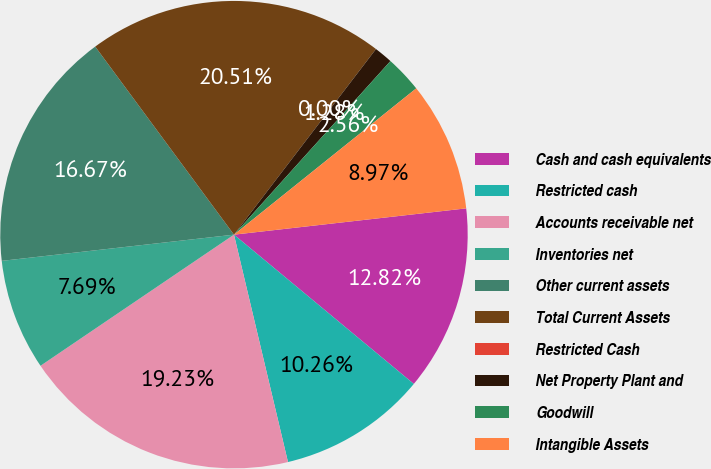<chart> <loc_0><loc_0><loc_500><loc_500><pie_chart><fcel>Cash and cash equivalents<fcel>Restricted cash<fcel>Accounts receivable net<fcel>Inventories net<fcel>Other current assets<fcel>Total Current Assets<fcel>Restricted Cash<fcel>Net Property Plant and<fcel>Goodwill<fcel>Intangible Assets<nl><fcel>12.82%<fcel>10.26%<fcel>19.23%<fcel>7.69%<fcel>16.67%<fcel>20.51%<fcel>0.0%<fcel>1.28%<fcel>2.56%<fcel>8.97%<nl></chart> 